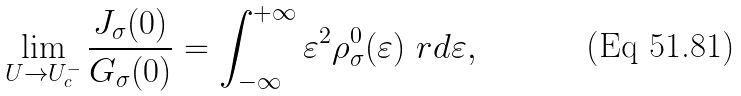Convert formula to latex. <formula><loc_0><loc_0><loc_500><loc_500>\lim _ { U \rightarrow U _ { c } ^ { - } } \frac { J _ { \sigma } ( 0 ) } { G _ { \sigma } ( 0 ) } = \int _ { - \infty } ^ { + \infty } \varepsilon ^ { 2 } \rho ^ { 0 } _ { \sigma } ( \varepsilon ) \ r d \varepsilon ,</formula> 